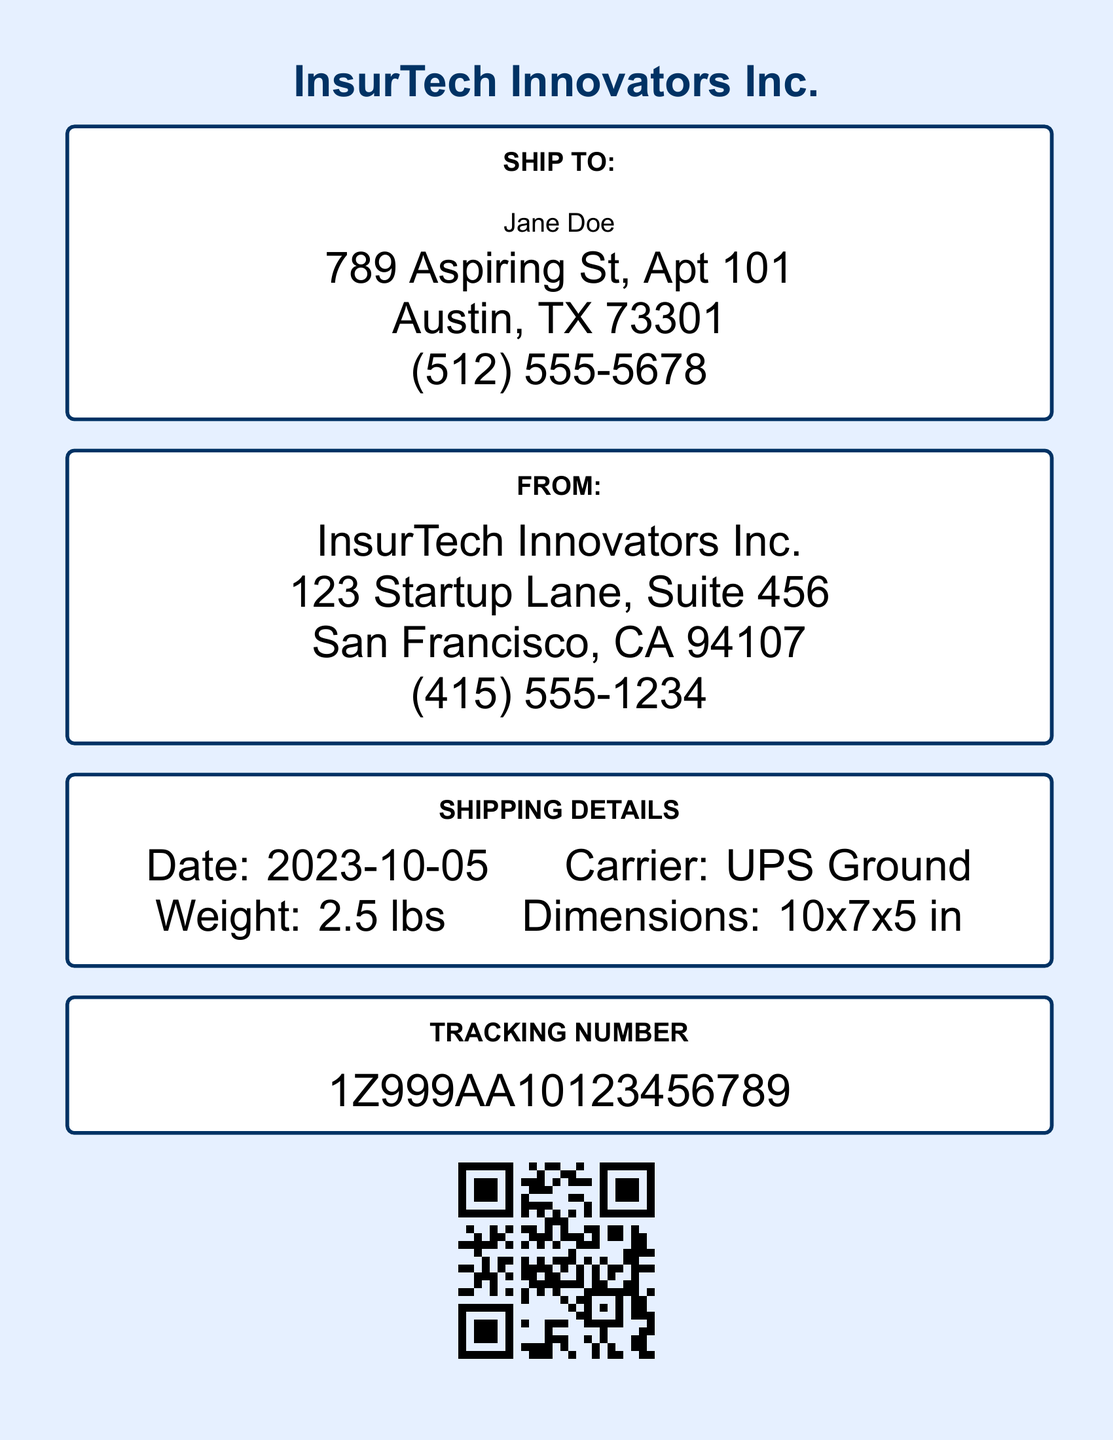What is the name of the recipient? The name of the recipient is found in the "SHIP TO" section of the document, which lists Jane Doe.
Answer: Jane Doe What is the shipping date? The shipping date is mentioned under the "SHIPPING DETAILS" section as 2023-10-05.
Answer: 2023-10-05 What is the tracking number? The tracking number is displayed prominently in the document as 1Z999AA10123456789.
Answer: 1Z999AA10123456789 What is the weight of the package? The weight of the package is specified in the "SHIPPING DETAILS" section, which states it is 2.5 lbs.
Answer: 2.5 lbs Who is the sender? The sender's information appears in the "FROM" section of the document, which identifies InsurTech Innovators Inc.
Answer: InsurTech Innovators Inc What city is the recipient located in? The recipient's address includes "Austin, TX," indicating the city is Austin.
Answer: Austin Which carrier is used for the shipment? The carrier for the shipment is noted in the "SHIPPING DETAILS" as UPS Ground.
Answer: UPS Ground What are the package dimensions? The dimensions of the package are listed in the "SHIPPING DETAILS" as 10x7x5 inches.
Answer: 10x7x5 in What is the phone number of the sender? The sender's phone number is available in the "FROM" section of the document, which is (415) 555-1234.
Answer: (415) 555-1234 